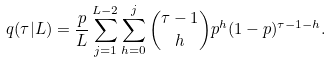<formula> <loc_0><loc_0><loc_500><loc_500>q ( \tau | L ) = \frac { p } { L } \sum _ { j = 1 } ^ { L - 2 } \sum _ { h = 0 } ^ { j } { \tau - 1 \choose h } p ^ { h } ( 1 - p ) ^ { \tau - 1 - h } .</formula> 